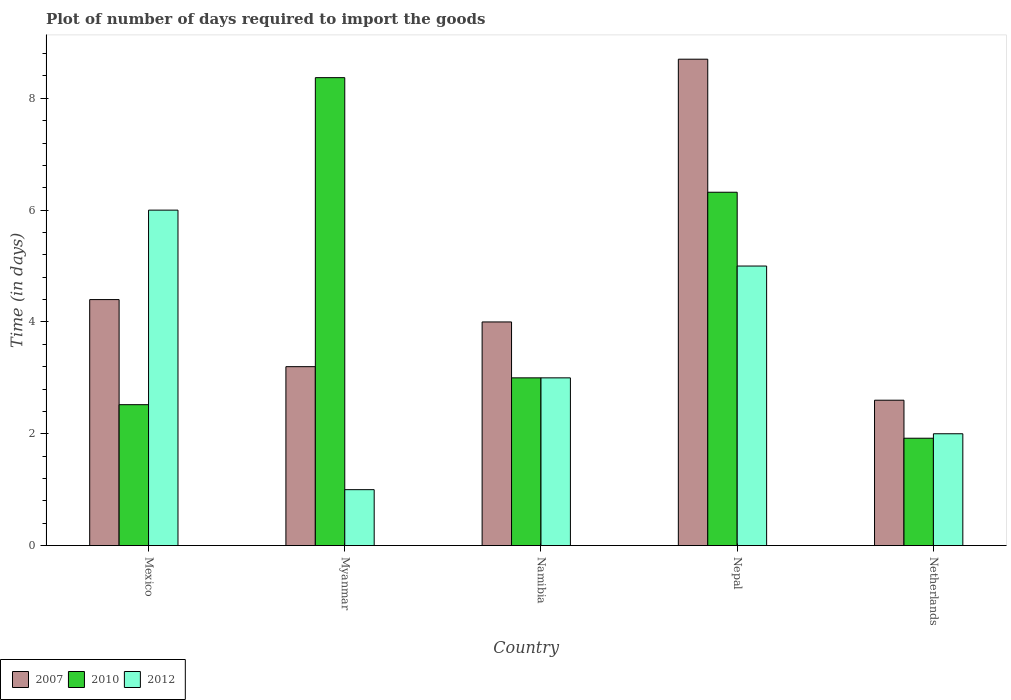How many groups of bars are there?
Give a very brief answer. 5. How many bars are there on the 2nd tick from the left?
Keep it short and to the point. 3. What is the label of the 3rd group of bars from the left?
Provide a succinct answer. Namibia. In how many cases, is the number of bars for a given country not equal to the number of legend labels?
Provide a succinct answer. 0. What is the time required to import goods in 2010 in Mexico?
Provide a succinct answer. 2.52. In which country was the time required to import goods in 2007 maximum?
Your answer should be very brief. Nepal. In which country was the time required to import goods in 2012 minimum?
Your answer should be very brief. Myanmar. What is the total time required to import goods in 2007 in the graph?
Keep it short and to the point. 22.9. What is the difference between the time required to import goods in 2007 in Mexico and that in Nepal?
Keep it short and to the point. -4.3. What is the difference between the time required to import goods in 2007 in Nepal and the time required to import goods in 2012 in Myanmar?
Provide a succinct answer. 7.7. What is the average time required to import goods in 2010 per country?
Give a very brief answer. 4.43. What is the difference between the time required to import goods of/in 2012 and time required to import goods of/in 2010 in Namibia?
Provide a succinct answer. 0. What is the ratio of the time required to import goods in 2010 in Mexico to that in Netherlands?
Offer a very short reply. 1.31. Is the difference between the time required to import goods in 2012 in Namibia and Nepal greater than the difference between the time required to import goods in 2010 in Namibia and Nepal?
Provide a short and direct response. Yes. What is the difference between the highest and the second highest time required to import goods in 2007?
Your answer should be very brief. 4.3. What is the difference between the highest and the lowest time required to import goods in 2007?
Make the answer very short. 6.1. In how many countries, is the time required to import goods in 2012 greater than the average time required to import goods in 2012 taken over all countries?
Give a very brief answer. 2. What does the 3rd bar from the right in Mexico represents?
Make the answer very short. 2007. Is it the case that in every country, the sum of the time required to import goods in 2010 and time required to import goods in 2007 is greater than the time required to import goods in 2012?
Give a very brief answer. Yes. How many bars are there?
Your answer should be compact. 15. Are all the bars in the graph horizontal?
Your answer should be compact. No. Are the values on the major ticks of Y-axis written in scientific E-notation?
Your answer should be compact. No. How many legend labels are there?
Your answer should be very brief. 3. What is the title of the graph?
Give a very brief answer. Plot of number of days required to import the goods. What is the label or title of the Y-axis?
Make the answer very short. Time (in days). What is the Time (in days) in 2010 in Mexico?
Your answer should be very brief. 2.52. What is the Time (in days) of 2012 in Mexico?
Give a very brief answer. 6. What is the Time (in days) in 2007 in Myanmar?
Ensure brevity in your answer.  3.2. What is the Time (in days) of 2010 in Myanmar?
Provide a succinct answer. 8.37. What is the Time (in days) of 2012 in Namibia?
Your answer should be compact. 3. What is the Time (in days) in 2007 in Nepal?
Make the answer very short. 8.7. What is the Time (in days) of 2010 in Nepal?
Your response must be concise. 6.32. What is the Time (in days) in 2012 in Nepal?
Give a very brief answer. 5. What is the Time (in days) of 2010 in Netherlands?
Keep it short and to the point. 1.92. Across all countries, what is the maximum Time (in days) in 2007?
Keep it short and to the point. 8.7. Across all countries, what is the maximum Time (in days) in 2010?
Offer a terse response. 8.37. Across all countries, what is the minimum Time (in days) in 2007?
Your response must be concise. 2.6. Across all countries, what is the minimum Time (in days) of 2010?
Your response must be concise. 1.92. Across all countries, what is the minimum Time (in days) in 2012?
Provide a succinct answer. 1. What is the total Time (in days) in 2007 in the graph?
Make the answer very short. 22.9. What is the total Time (in days) of 2010 in the graph?
Ensure brevity in your answer.  22.13. What is the total Time (in days) of 2012 in the graph?
Your answer should be very brief. 17. What is the difference between the Time (in days) of 2007 in Mexico and that in Myanmar?
Provide a succinct answer. 1.2. What is the difference between the Time (in days) of 2010 in Mexico and that in Myanmar?
Offer a very short reply. -5.85. What is the difference between the Time (in days) in 2007 in Mexico and that in Namibia?
Ensure brevity in your answer.  0.4. What is the difference between the Time (in days) of 2010 in Mexico and that in Namibia?
Keep it short and to the point. -0.48. What is the difference between the Time (in days) of 2007 in Mexico and that in Nepal?
Your answer should be very brief. -4.3. What is the difference between the Time (in days) in 2010 in Mexico and that in Nepal?
Your answer should be compact. -3.8. What is the difference between the Time (in days) in 2012 in Mexico and that in Nepal?
Your answer should be very brief. 1. What is the difference between the Time (in days) of 2007 in Mexico and that in Netherlands?
Your answer should be very brief. 1.8. What is the difference between the Time (in days) of 2007 in Myanmar and that in Namibia?
Ensure brevity in your answer.  -0.8. What is the difference between the Time (in days) in 2010 in Myanmar and that in Namibia?
Provide a succinct answer. 5.37. What is the difference between the Time (in days) in 2012 in Myanmar and that in Namibia?
Your answer should be compact. -2. What is the difference between the Time (in days) of 2010 in Myanmar and that in Nepal?
Make the answer very short. 2.05. What is the difference between the Time (in days) of 2012 in Myanmar and that in Nepal?
Provide a succinct answer. -4. What is the difference between the Time (in days) of 2010 in Myanmar and that in Netherlands?
Make the answer very short. 6.45. What is the difference between the Time (in days) in 2007 in Namibia and that in Nepal?
Ensure brevity in your answer.  -4.7. What is the difference between the Time (in days) of 2010 in Namibia and that in Nepal?
Provide a succinct answer. -3.32. What is the difference between the Time (in days) in 2007 in Namibia and that in Netherlands?
Keep it short and to the point. 1.4. What is the difference between the Time (in days) of 2007 in Nepal and that in Netherlands?
Provide a succinct answer. 6.1. What is the difference between the Time (in days) in 2010 in Nepal and that in Netherlands?
Give a very brief answer. 4.4. What is the difference between the Time (in days) of 2012 in Nepal and that in Netherlands?
Your answer should be very brief. 3. What is the difference between the Time (in days) of 2007 in Mexico and the Time (in days) of 2010 in Myanmar?
Provide a short and direct response. -3.97. What is the difference between the Time (in days) of 2007 in Mexico and the Time (in days) of 2012 in Myanmar?
Offer a terse response. 3.4. What is the difference between the Time (in days) in 2010 in Mexico and the Time (in days) in 2012 in Myanmar?
Offer a very short reply. 1.52. What is the difference between the Time (in days) of 2007 in Mexico and the Time (in days) of 2012 in Namibia?
Provide a succinct answer. 1.4. What is the difference between the Time (in days) of 2010 in Mexico and the Time (in days) of 2012 in Namibia?
Offer a very short reply. -0.48. What is the difference between the Time (in days) in 2007 in Mexico and the Time (in days) in 2010 in Nepal?
Keep it short and to the point. -1.92. What is the difference between the Time (in days) of 2007 in Mexico and the Time (in days) of 2012 in Nepal?
Offer a very short reply. -0.6. What is the difference between the Time (in days) in 2010 in Mexico and the Time (in days) in 2012 in Nepal?
Make the answer very short. -2.48. What is the difference between the Time (in days) in 2007 in Mexico and the Time (in days) in 2010 in Netherlands?
Give a very brief answer. 2.48. What is the difference between the Time (in days) of 2007 in Mexico and the Time (in days) of 2012 in Netherlands?
Keep it short and to the point. 2.4. What is the difference between the Time (in days) of 2010 in Mexico and the Time (in days) of 2012 in Netherlands?
Your answer should be very brief. 0.52. What is the difference between the Time (in days) of 2007 in Myanmar and the Time (in days) of 2010 in Namibia?
Ensure brevity in your answer.  0.2. What is the difference between the Time (in days) in 2007 in Myanmar and the Time (in days) in 2012 in Namibia?
Your response must be concise. 0.2. What is the difference between the Time (in days) of 2010 in Myanmar and the Time (in days) of 2012 in Namibia?
Give a very brief answer. 5.37. What is the difference between the Time (in days) in 2007 in Myanmar and the Time (in days) in 2010 in Nepal?
Provide a short and direct response. -3.12. What is the difference between the Time (in days) of 2007 in Myanmar and the Time (in days) of 2012 in Nepal?
Your response must be concise. -1.8. What is the difference between the Time (in days) in 2010 in Myanmar and the Time (in days) in 2012 in Nepal?
Provide a short and direct response. 3.37. What is the difference between the Time (in days) in 2007 in Myanmar and the Time (in days) in 2010 in Netherlands?
Keep it short and to the point. 1.28. What is the difference between the Time (in days) in 2007 in Myanmar and the Time (in days) in 2012 in Netherlands?
Make the answer very short. 1.2. What is the difference between the Time (in days) in 2010 in Myanmar and the Time (in days) in 2012 in Netherlands?
Your answer should be very brief. 6.37. What is the difference between the Time (in days) of 2007 in Namibia and the Time (in days) of 2010 in Nepal?
Offer a terse response. -2.32. What is the difference between the Time (in days) in 2010 in Namibia and the Time (in days) in 2012 in Nepal?
Ensure brevity in your answer.  -2. What is the difference between the Time (in days) of 2007 in Namibia and the Time (in days) of 2010 in Netherlands?
Provide a succinct answer. 2.08. What is the difference between the Time (in days) in 2007 in Namibia and the Time (in days) in 2012 in Netherlands?
Offer a very short reply. 2. What is the difference between the Time (in days) in 2007 in Nepal and the Time (in days) in 2010 in Netherlands?
Your answer should be compact. 6.78. What is the difference between the Time (in days) in 2007 in Nepal and the Time (in days) in 2012 in Netherlands?
Keep it short and to the point. 6.7. What is the difference between the Time (in days) in 2010 in Nepal and the Time (in days) in 2012 in Netherlands?
Keep it short and to the point. 4.32. What is the average Time (in days) in 2007 per country?
Make the answer very short. 4.58. What is the average Time (in days) in 2010 per country?
Your answer should be compact. 4.43. What is the average Time (in days) in 2012 per country?
Provide a short and direct response. 3.4. What is the difference between the Time (in days) in 2007 and Time (in days) in 2010 in Mexico?
Make the answer very short. 1.88. What is the difference between the Time (in days) of 2007 and Time (in days) of 2012 in Mexico?
Your answer should be very brief. -1.6. What is the difference between the Time (in days) of 2010 and Time (in days) of 2012 in Mexico?
Give a very brief answer. -3.48. What is the difference between the Time (in days) in 2007 and Time (in days) in 2010 in Myanmar?
Provide a short and direct response. -5.17. What is the difference between the Time (in days) of 2010 and Time (in days) of 2012 in Myanmar?
Offer a terse response. 7.37. What is the difference between the Time (in days) of 2007 and Time (in days) of 2010 in Namibia?
Provide a succinct answer. 1. What is the difference between the Time (in days) in 2007 and Time (in days) in 2012 in Namibia?
Your answer should be compact. 1. What is the difference between the Time (in days) in 2010 and Time (in days) in 2012 in Namibia?
Keep it short and to the point. 0. What is the difference between the Time (in days) in 2007 and Time (in days) in 2010 in Nepal?
Your answer should be very brief. 2.38. What is the difference between the Time (in days) of 2010 and Time (in days) of 2012 in Nepal?
Offer a terse response. 1.32. What is the difference between the Time (in days) in 2007 and Time (in days) in 2010 in Netherlands?
Keep it short and to the point. 0.68. What is the difference between the Time (in days) in 2010 and Time (in days) in 2012 in Netherlands?
Ensure brevity in your answer.  -0.08. What is the ratio of the Time (in days) in 2007 in Mexico to that in Myanmar?
Ensure brevity in your answer.  1.38. What is the ratio of the Time (in days) of 2010 in Mexico to that in Myanmar?
Give a very brief answer. 0.3. What is the ratio of the Time (in days) of 2012 in Mexico to that in Myanmar?
Provide a succinct answer. 6. What is the ratio of the Time (in days) in 2010 in Mexico to that in Namibia?
Your answer should be compact. 0.84. What is the ratio of the Time (in days) in 2007 in Mexico to that in Nepal?
Offer a terse response. 0.51. What is the ratio of the Time (in days) in 2010 in Mexico to that in Nepal?
Offer a terse response. 0.4. What is the ratio of the Time (in days) of 2007 in Mexico to that in Netherlands?
Give a very brief answer. 1.69. What is the ratio of the Time (in days) of 2010 in Mexico to that in Netherlands?
Your answer should be very brief. 1.31. What is the ratio of the Time (in days) in 2012 in Mexico to that in Netherlands?
Provide a short and direct response. 3. What is the ratio of the Time (in days) in 2007 in Myanmar to that in Namibia?
Provide a succinct answer. 0.8. What is the ratio of the Time (in days) in 2010 in Myanmar to that in Namibia?
Offer a very short reply. 2.79. What is the ratio of the Time (in days) of 2007 in Myanmar to that in Nepal?
Provide a succinct answer. 0.37. What is the ratio of the Time (in days) of 2010 in Myanmar to that in Nepal?
Ensure brevity in your answer.  1.32. What is the ratio of the Time (in days) of 2007 in Myanmar to that in Netherlands?
Provide a short and direct response. 1.23. What is the ratio of the Time (in days) in 2010 in Myanmar to that in Netherlands?
Keep it short and to the point. 4.36. What is the ratio of the Time (in days) of 2007 in Namibia to that in Nepal?
Keep it short and to the point. 0.46. What is the ratio of the Time (in days) in 2010 in Namibia to that in Nepal?
Provide a short and direct response. 0.47. What is the ratio of the Time (in days) of 2012 in Namibia to that in Nepal?
Ensure brevity in your answer.  0.6. What is the ratio of the Time (in days) of 2007 in Namibia to that in Netherlands?
Offer a very short reply. 1.54. What is the ratio of the Time (in days) in 2010 in Namibia to that in Netherlands?
Offer a terse response. 1.56. What is the ratio of the Time (in days) of 2007 in Nepal to that in Netherlands?
Make the answer very short. 3.35. What is the ratio of the Time (in days) of 2010 in Nepal to that in Netherlands?
Give a very brief answer. 3.29. What is the difference between the highest and the second highest Time (in days) of 2010?
Provide a short and direct response. 2.05. What is the difference between the highest and the second highest Time (in days) in 2012?
Make the answer very short. 1. What is the difference between the highest and the lowest Time (in days) of 2010?
Offer a terse response. 6.45. 